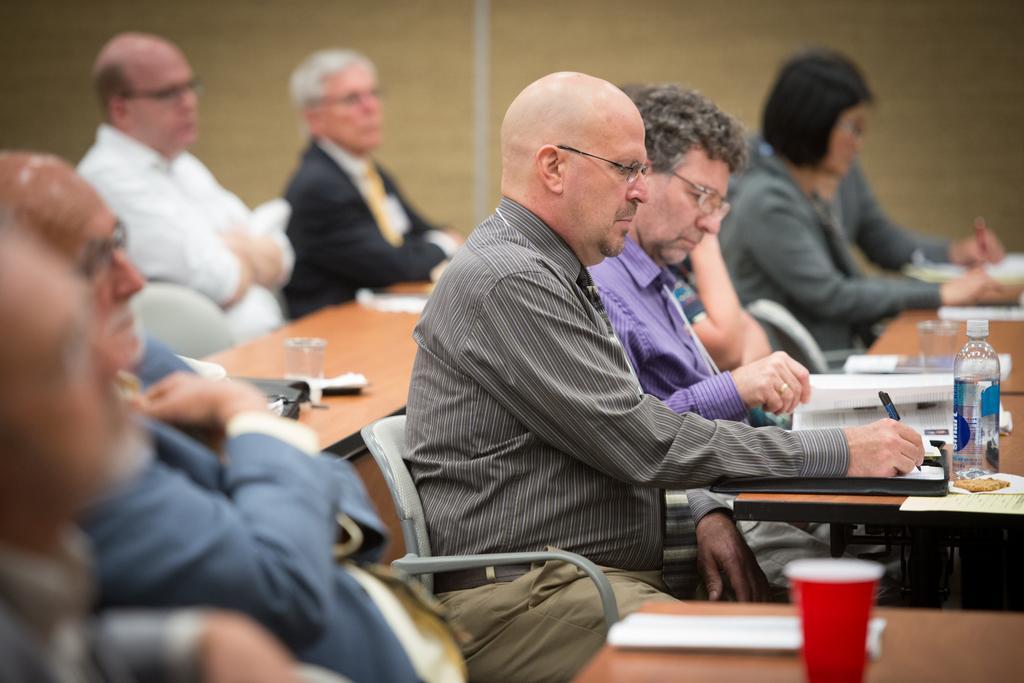Could you give a brief overview of what you see in this image? In this image there are group of persons who are sitting on the chairs and doing some work. 